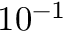<formula> <loc_0><loc_0><loc_500><loc_500>1 0 ^ { - 1 }</formula> 